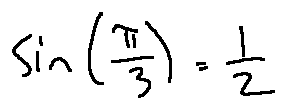Convert formula to latex. <formula><loc_0><loc_0><loc_500><loc_500>\sin ( \frac { \pi } { 3 } ) = \frac { 1 } { 2 }</formula> 